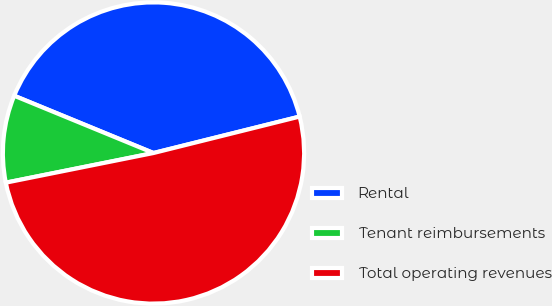Convert chart. <chart><loc_0><loc_0><loc_500><loc_500><pie_chart><fcel>Rental<fcel>Tenant reimbursements<fcel>Total operating revenues<nl><fcel>39.9%<fcel>9.36%<fcel>50.73%<nl></chart> 